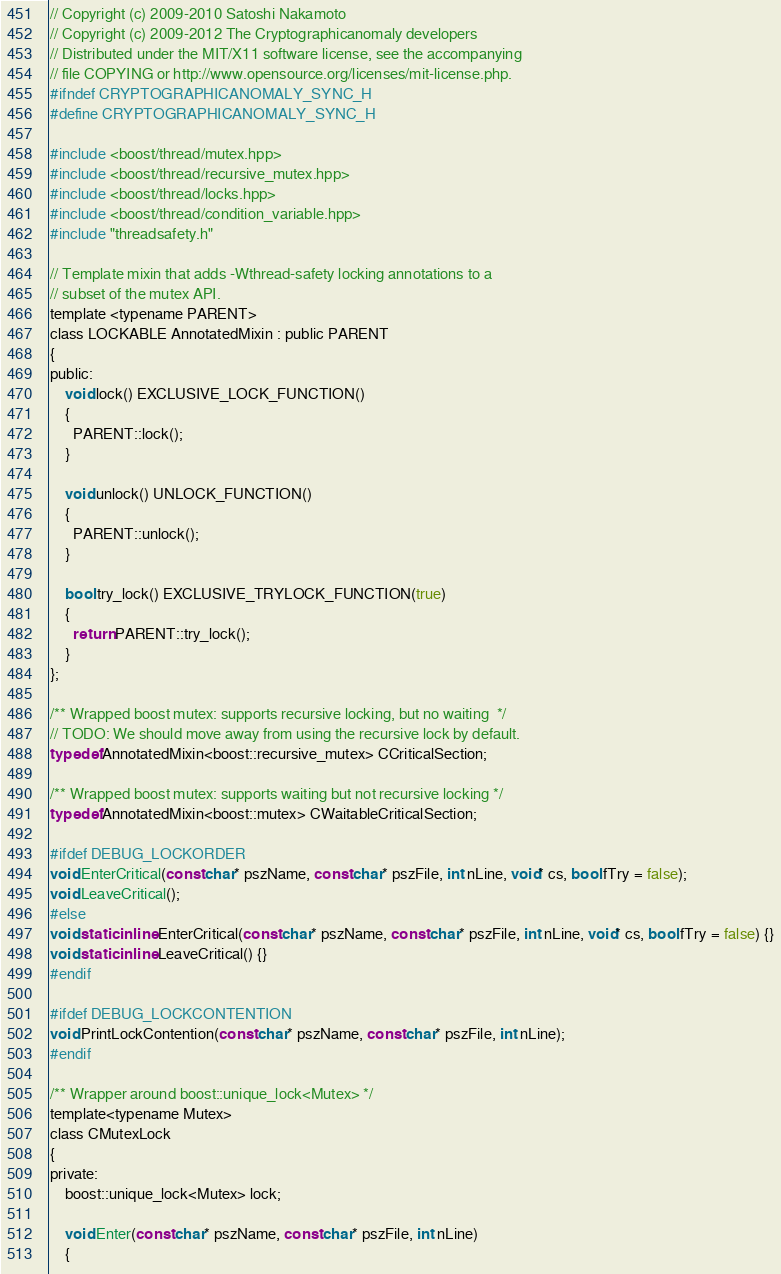Convert code to text. <code><loc_0><loc_0><loc_500><loc_500><_C_>// Copyright (c) 2009-2010 Satoshi Nakamoto
// Copyright (c) 2009-2012 The Cryptographicanomaly developers
// Distributed under the MIT/X11 software license, see the accompanying
// file COPYING or http://www.opensource.org/licenses/mit-license.php.
#ifndef CRYPTOGRAPHICANOMALY_SYNC_H
#define CRYPTOGRAPHICANOMALY_SYNC_H

#include <boost/thread/mutex.hpp>
#include <boost/thread/recursive_mutex.hpp>
#include <boost/thread/locks.hpp>
#include <boost/thread/condition_variable.hpp>
#include "threadsafety.h"

// Template mixin that adds -Wthread-safety locking annotations to a
// subset of the mutex API.
template <typename PARENT>
class LOCKABLE AnnotatedMixin : public PARENT
{
public:
    void lock() EXCLUSIVE_LOCK_FUNCTION()
    {
      PARENT::lock();
    }

    void unlock() UNLOCK_FUNCTION()
    {
      PARENT::unlock();
    }

    bool try_lock() EXCLUSIVE_TRYLOCK_FUNCTION(true)
    {
      return PARENT::try_lock();
    }
};

/** Wrapped boost mutex: supports recursive locking, but no waiting  */
// TODO: We should move away from using the recursive lock by default.
typedef AnnotatedMixin<boost::recursive_mutex> CCriticalSection;

/** Wrapped boost mutex: supports waiting but not recursive locking */
typedef AnnotatedMixin<boost::mutex> CWaitableCriticalSection;

#ifdef DEBUG_LOCKORDER
void EnterCritical(const char* pszName, const char* pszFile, int nLine, void* cs, bool fTry = false);
void LeaveCritical();
#else
void static inline EnterCritical(const char* pszName, const char* pszFile, int nLine, void* cs, bool fTry = false) {}
void static inline LeaveCritical() {}
#endif

#ifdef DEBUG_LOCKCONTENTION
void PrintLockContention(const char* pszName, const char* pszFile, int nLine);
#endif

/** Wrapper around boost::unique_lock<Mutex> */
template<typename Mutex>
class CMutexLock
{
private:
    boost::unique_lock<Mutex> lock;

    void Enter(const char* pszName, const char* pszFile, int nLine)
    {</code> 